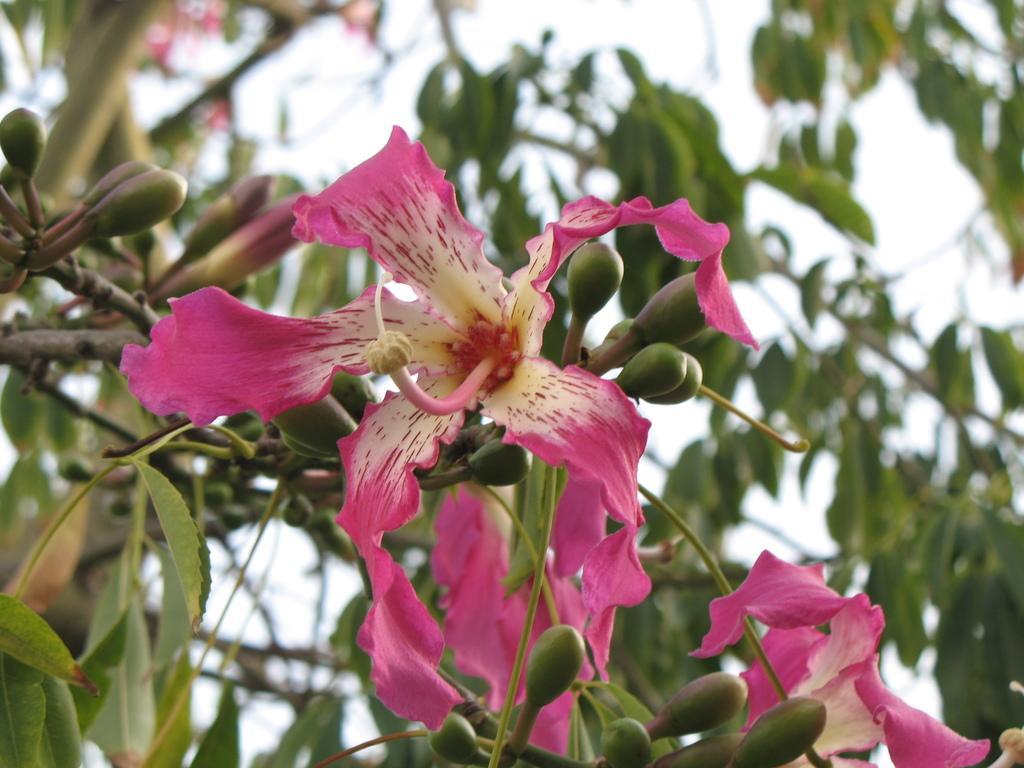Can you describe this image briefly? In this image there is a tree for that tree there are flowers and buds, in the background it is blurred. 